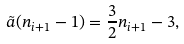<formula> <loc_0><loc_0><loc_500><loc_500>\tilde { a } ( n _ { i + 1 } - 1 ) = \frac { 3 } { 2 } n _ { i + 1 } - 3 ,</formula> 